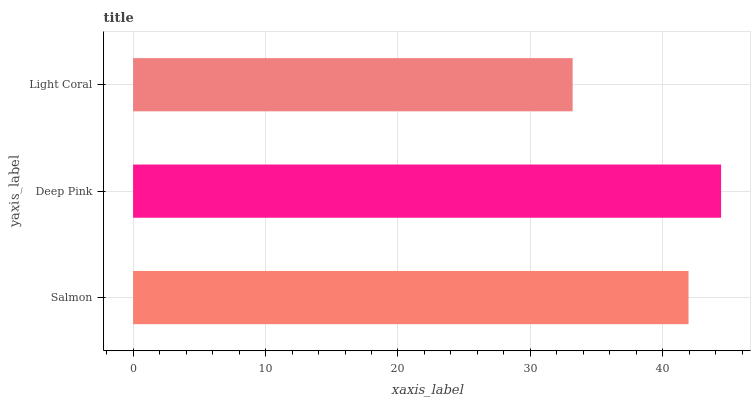Is Light Coral the minimum?
Answer yes or no. Yes. Is Deep Pink the maximum?
Answer yes or no. Yes. Is Deep Pink the minimum?
Answer yes or no. No. Is Light Coral the maximum?
Answer yes or no. No. Is Deep Pink greater than Light Coral?
Answer yes or no. Yes. Is Light Coral less than Deep Pink?
Answer yes or no. Yes. Is Light Coral greater than Deep Pink?
Answer yes or no. No. Is Deep Pink less than Light Coral?
Answer yes or no. No. Is Salmon the high median?
Answer yes or no. Yes. Is Salmon the low median?
Answer yes or no. Yes. Is Light Coral the high median?
Answer yes or no. No. Is Deep Pink the low median?
Answer yes or no. No. 